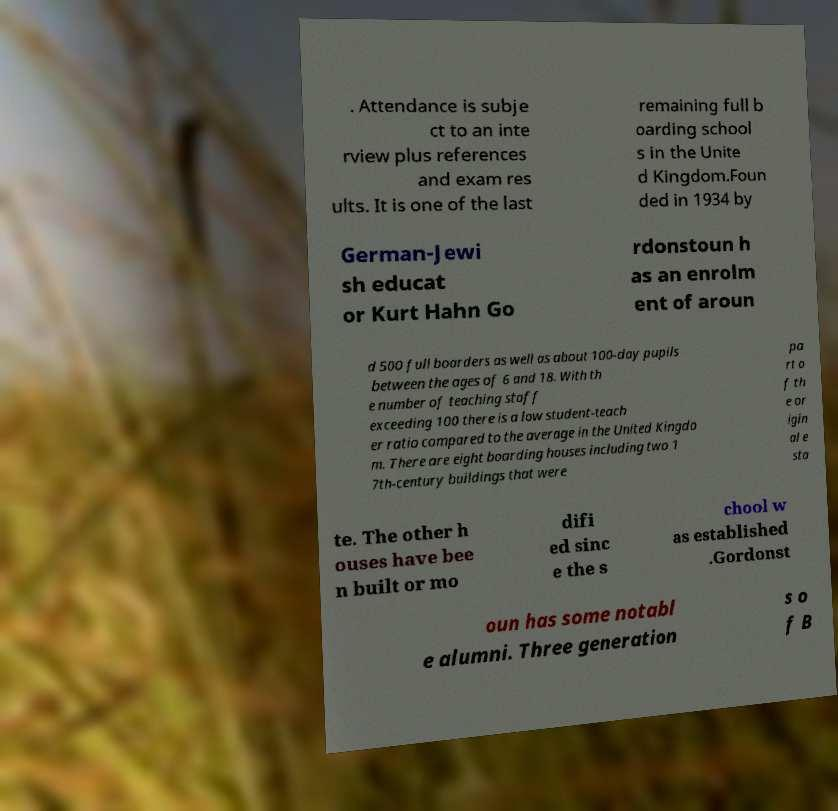Could you assist in decoding the text presented in this image and type it out clearly? . Attendance is subje ct to an inte rview plus references and exam res ults. It is one of the last remaining full b oarding school s in the Unite d Kingdom.Foun ded in 1934 by German-Jewi sh educat or Kurt Hahn Go rdonstoun h as an enrolm ent of aroun d 500 full boarders as well as about 100-day pupils between the ages of 6 and 18. With th e number of teaching staff exceeding 100 there is a low student-teach er ratio compared to the average in the United Kingdo m. There are eight boarding houses including two 1 7th-century buildings that were pa rt o f th e or igin al e sta te. The other h ouses have bee n built or mo difi ed sinc e the s chool w as established .Gordonst oun has some notabl e alumni. Three generation s o f B 